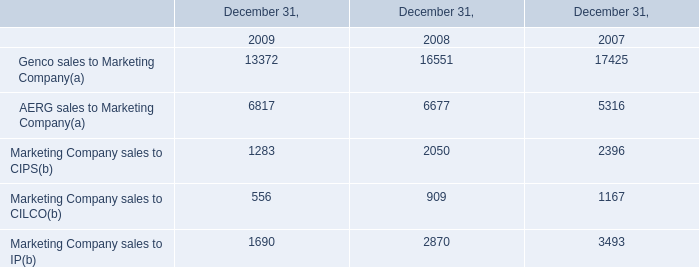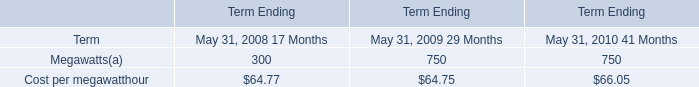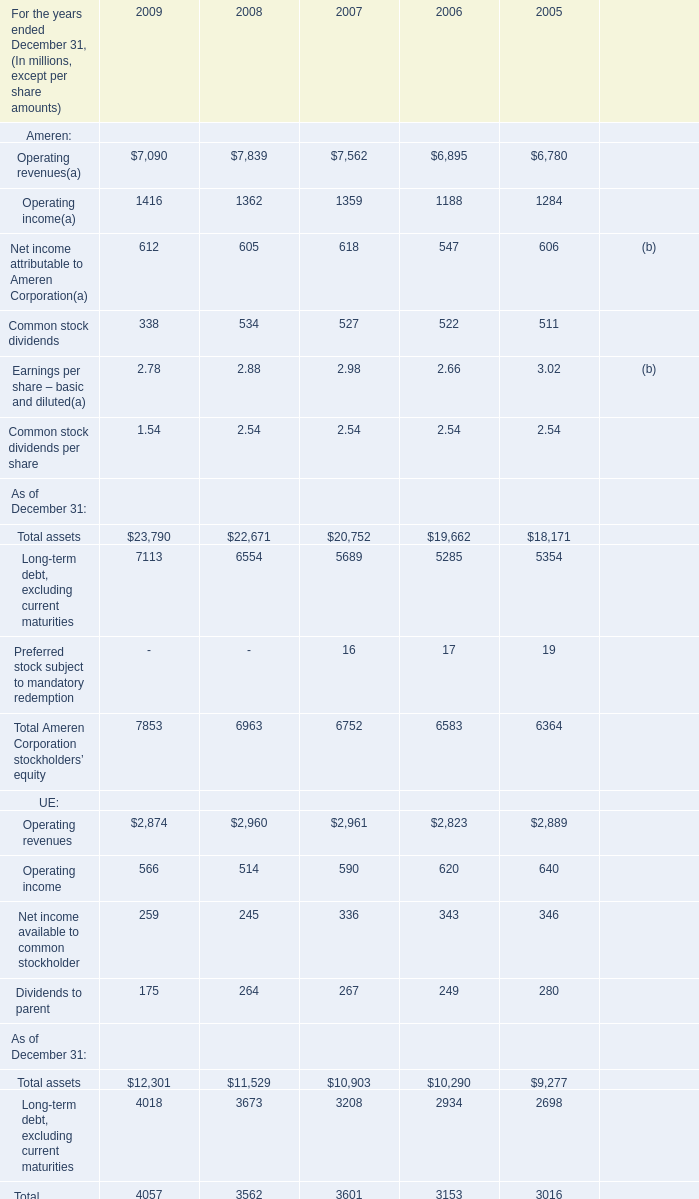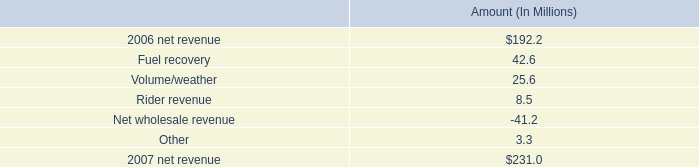In the year with the most Ameren: Operating revenues, what is the growth rate of Ameren: Operating income? 
Computations: ((1362 - 1359) / 1359)
Answer: 0.00221. 